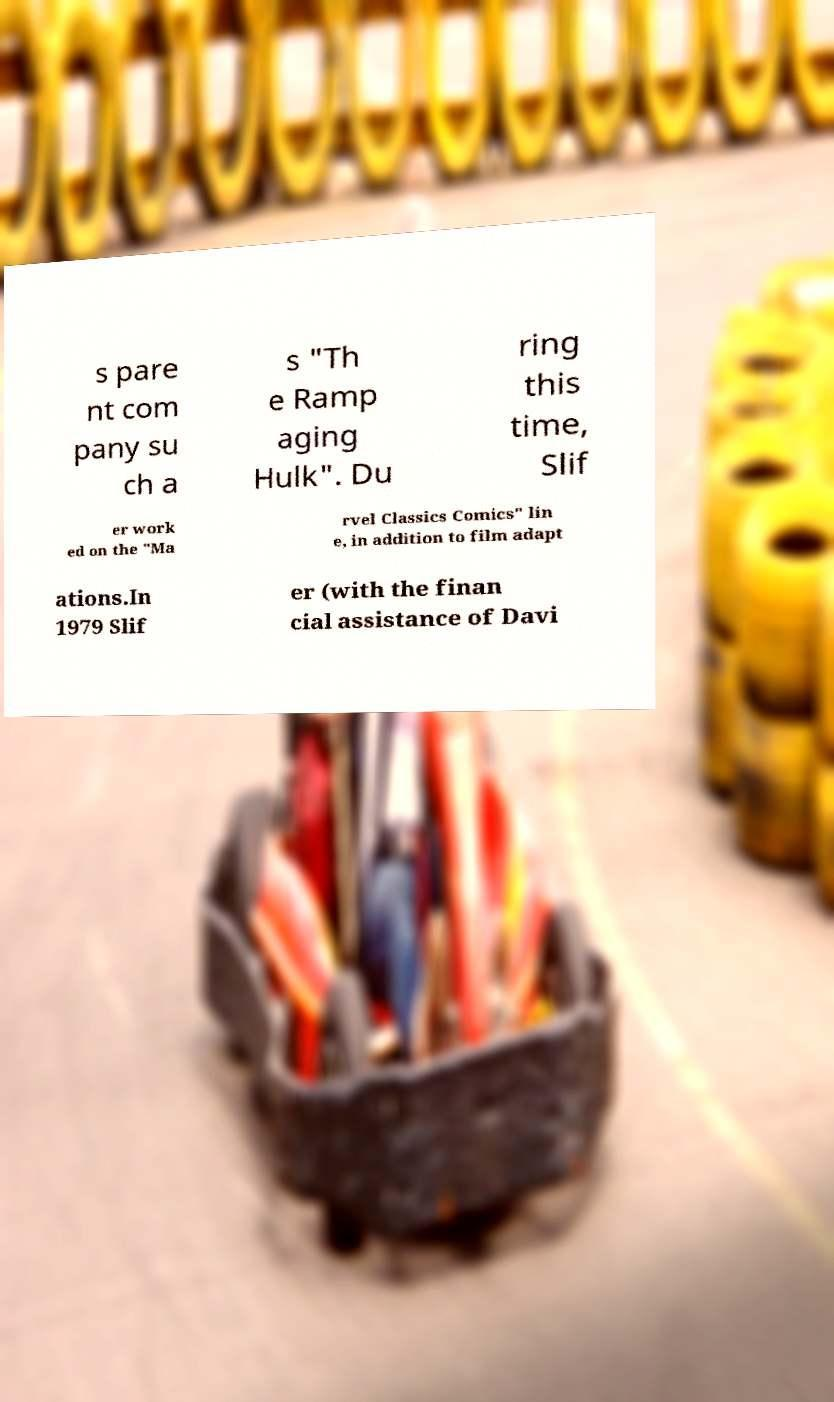Please identify and transcribe the text found in this image. s pare nt com pany su ch a s "Th e Ramp aging Hulk". Du ring this time, Slif er work ed on the "Ma rvel Classics Comics" lin e, in addition to film adapt ations.In 1979 Slif er (with the finan cial assistance of Davi 